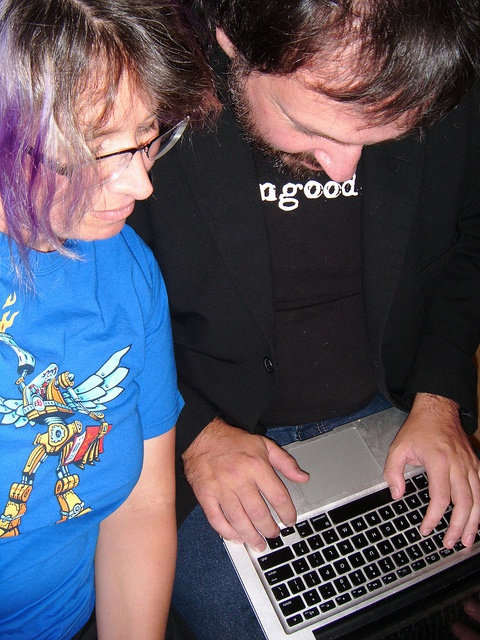Describe the objects in this image and their specific colors. I can see people in gray, black, lightpink, brown, and navy tones, people in gray, lightblue, lightpink, black, and blue tones, and laptop in gray, black, darkgray, and lightgray tones in this image. 